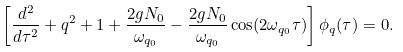<formula> <loc_0><loc_0><loc_500><loc_500>\left [ \frac { d ^ { 2 } } { d \tau ^ { 2 } } + q ^ { 2 } + 1 + \frac { 2 g N _ { 0 } } { \omega _ { q _ { 0 } } } - \frac { 2 g N _ { 0 } } { \omega _ { q _ { 0 } } } \cos ( 2 \omega _ { q _ { 0 } } \tau ) \right ] \phi _ { q } ( \tau ) = 0 .</formula> 